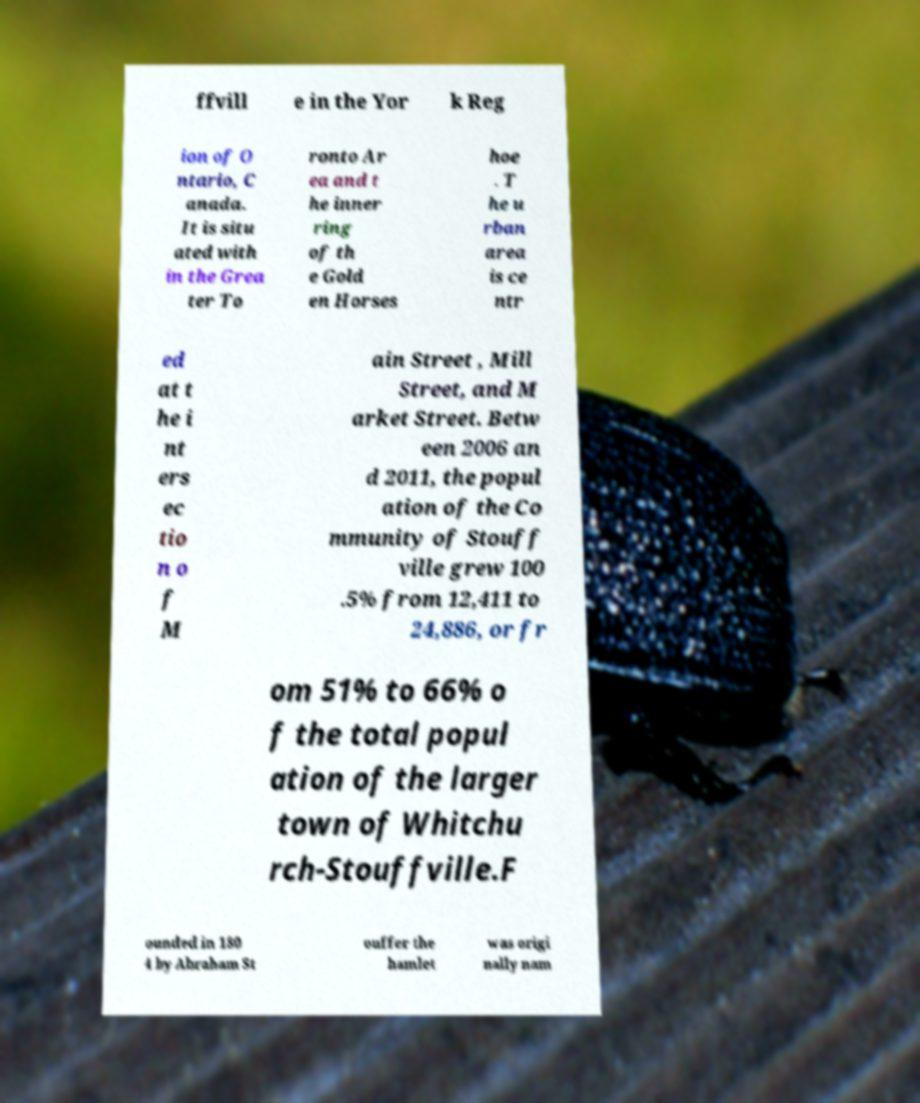Could you extract and type out the text from this image? ffvill e in the Yor k Reg ion of O ntario, C anada. It is situ ated with in the Grea ter To ronto Ar ea and t he inner ring of th e Gold en Horses hoe . T he u rban area is ce ntr ed at t he i nt ers ec tio n o f M ain Street , Mill Street, and M arket Street. Betw een 2006 an d 2011, the popul ation of the Co mmunity of Stouff ville grew 100 .5% from 12,411 to 24,886, or fr om 51% to 66% o f the total popul ation of the larger town of Whitchu rch-Stouffville.F ounded in 180 4 by Abraham St ouffer the hamlet was origi nally nam 